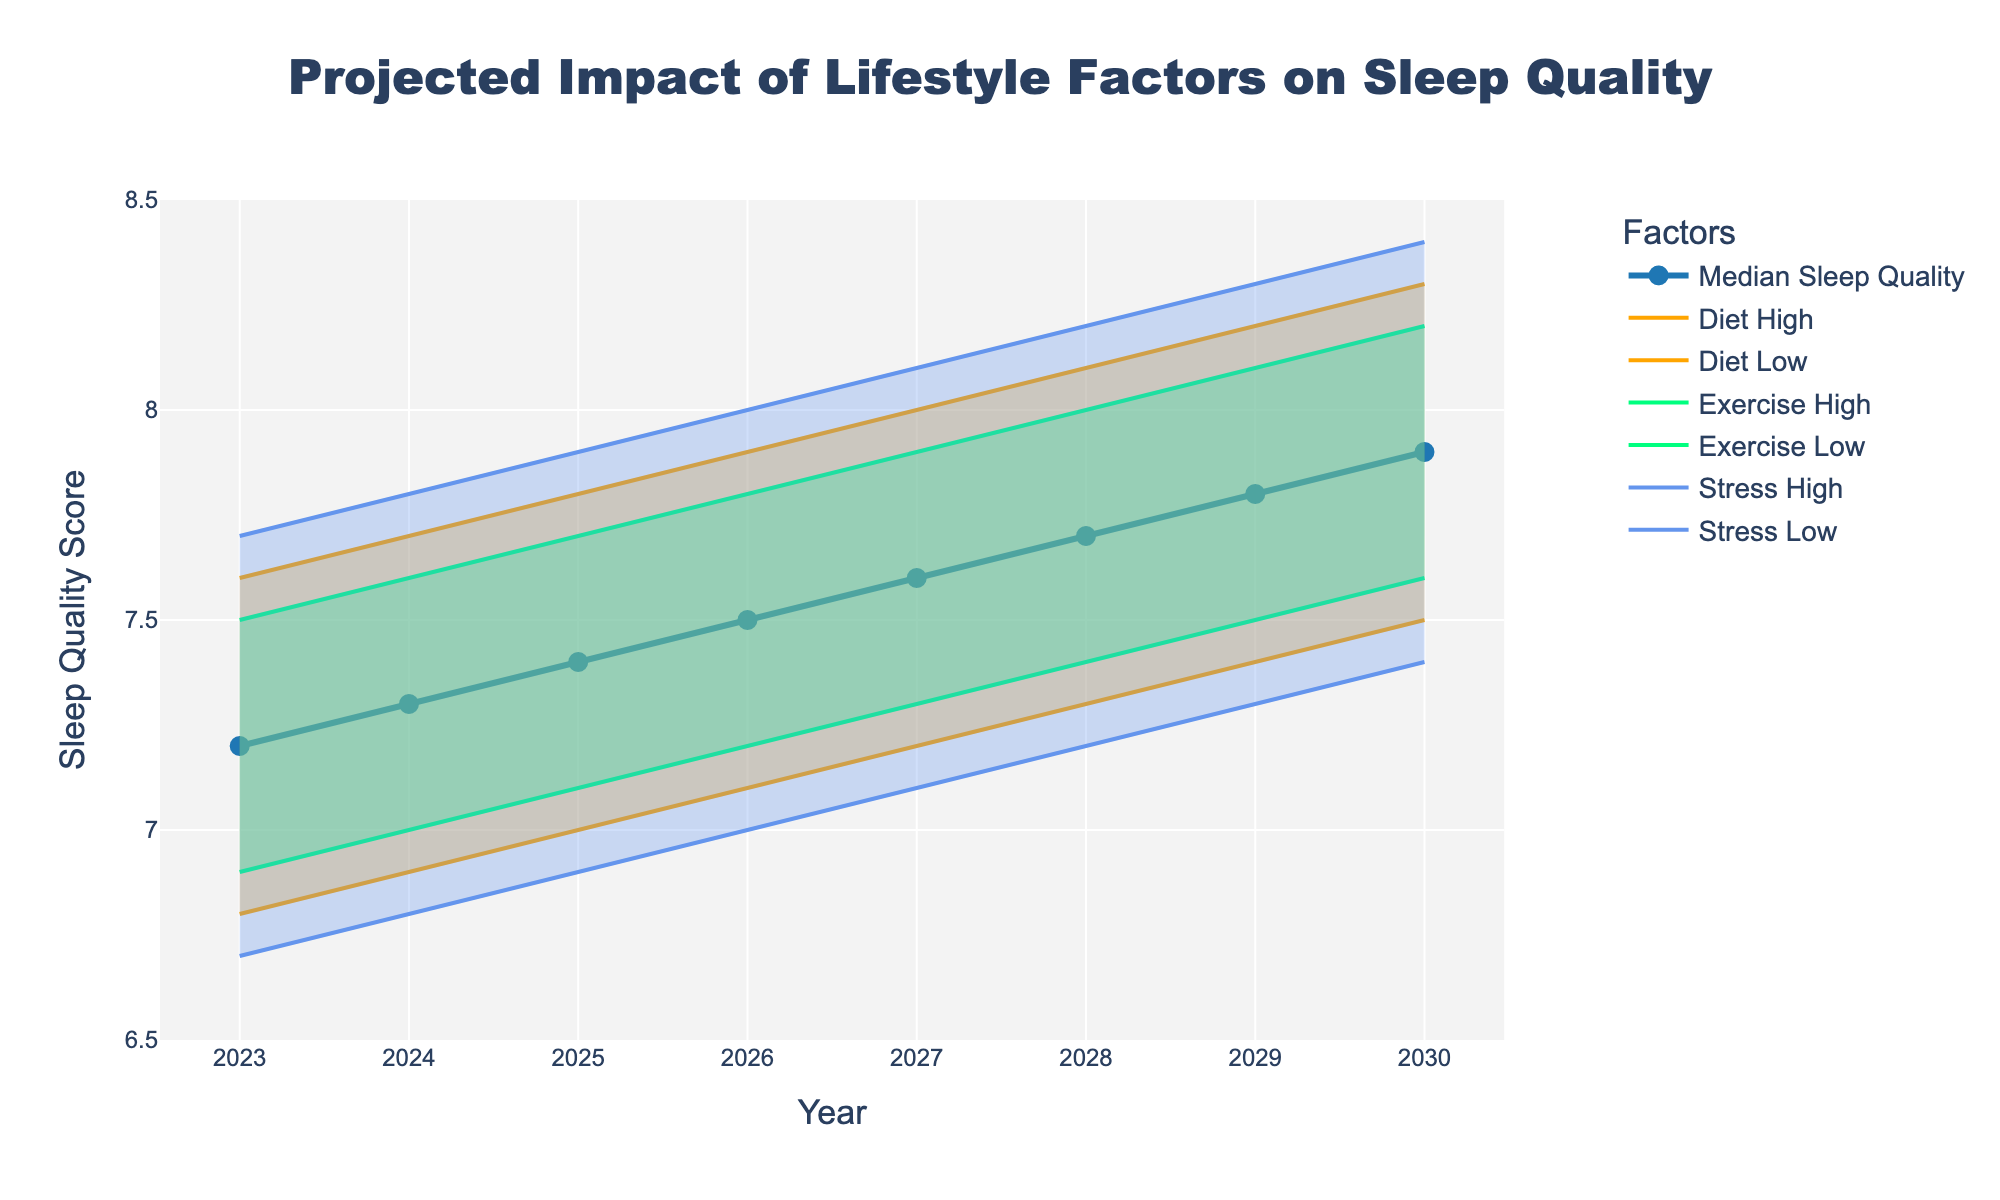What is the title of the chart? The title of a chart is typically located at the top center. From the visual information, it states the main subject of the chart.
Answer: Projected Impact of Lifestyle Factors on Sleep Quality How many years are plotted on the x-axis? The x-axis labels years from 2023 to 2030, visibly counting in sequence.
Answer: 8 What is the range of the y-axis for Sleep Quality Score? The y-axis range can be observed by looking at the bottom and top labels of the axis.
Answer: 6.5 to 8.5 Which lifestyle factor appears to have the broadest high and low boundaries over time? By comparing the width of the shaded areas for each lifestyle factor (diet, exercise, stress) across the chart, the factor with the broadest range stands out.
Answer: Stress What is the median sleep quality score projected for the year 2025? Locate the data point for the year 2025 along the median line, marked by a symbol.
Answer: 7.4 By how much does the median sleep quality score increase from 2023 to 2030? Find and subtract the value for 2023 from the value for 2030 along the median line.
Answer: 0.7 Which year shows the lowest high boundary for the diet factor? Observe the highest points of the shaded areas for the diet factor across all years, then find the lowest.
Answer: 2023 In which year does the median sleep quality score reach 7.6? Identify the point where the median line hits the score of 7.6 on the y-axis.
Answer: 2027 How does the impact of exercise on sleep quality in 2028 compare to the impact of diet in the same year? Examine the high and low boundaries for both exercise and diet in 2028. Compare the upper limit and lower limit for each factor.
Answer: Exercise has a higher impact range than diet What is the difference between the high boundary of stress and the high boundary of exercise for the year 2026? Locate the high boundaries for stress and exercise for 2026 and calculate the difference between these two values.
Answer: 0.2 